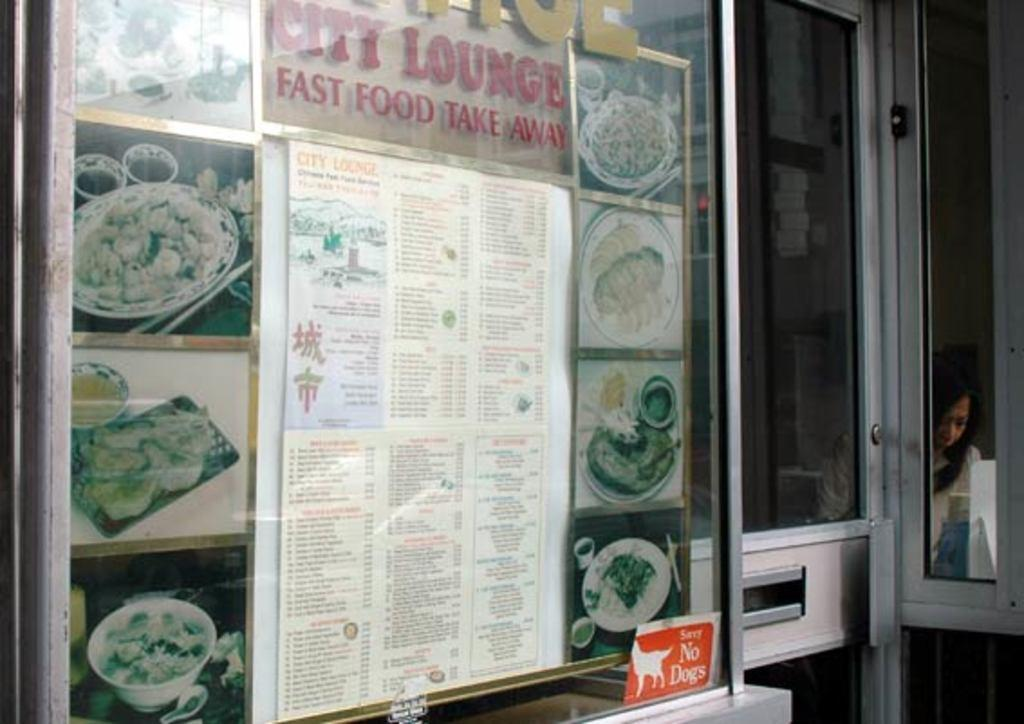<image>
Render a clear and concise summary of the photo. A lounge's menu is on the window outside of the building. 